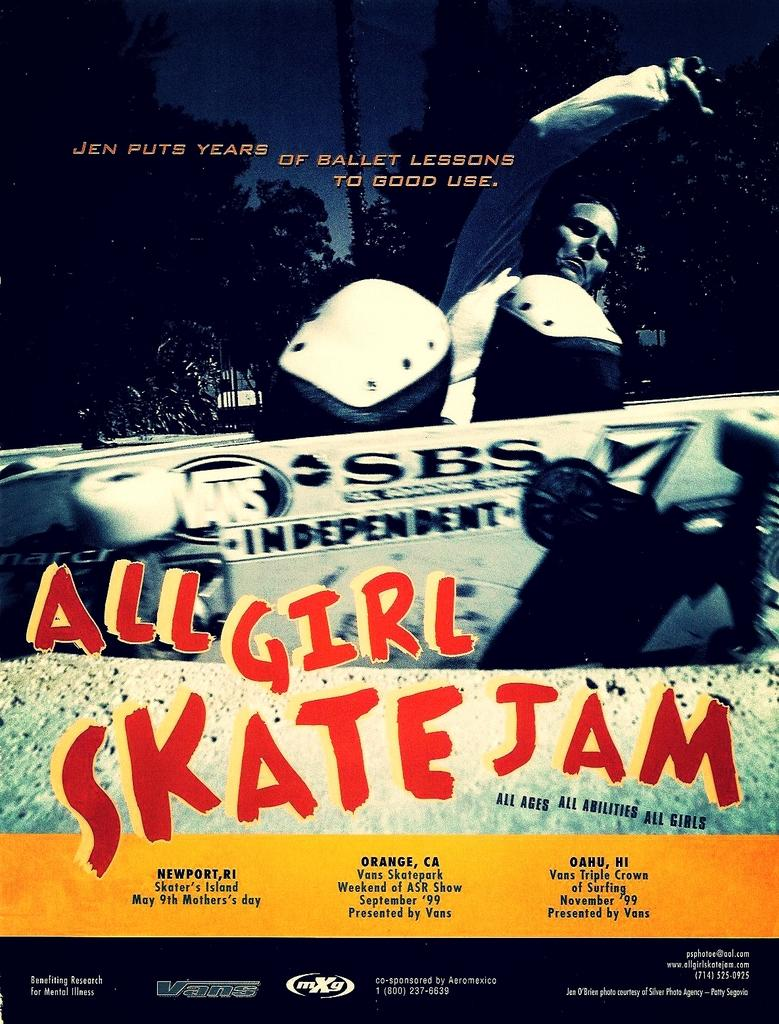What is the main subject of the image? There is a person in the image. What else can be seen in the image besides the person? There is text, a board, trees, logos, a building, a vehicle, and the sky visible in the image. Can you describe the board in the image? There is a board in the image, but no specific details about its appearance or content are provided. What type of vehicle is present in the image? The type of vehicle is not specified in the provided facts. Can you tell me how many knives are on the floor in the image? There is no mention of knives or a floor in the provided facts, so it cannot be determined from the image. What advice is the person in the image giving to the viewer? There is no indication of the person giving advice or interacting with the viewer in the provided facts. 